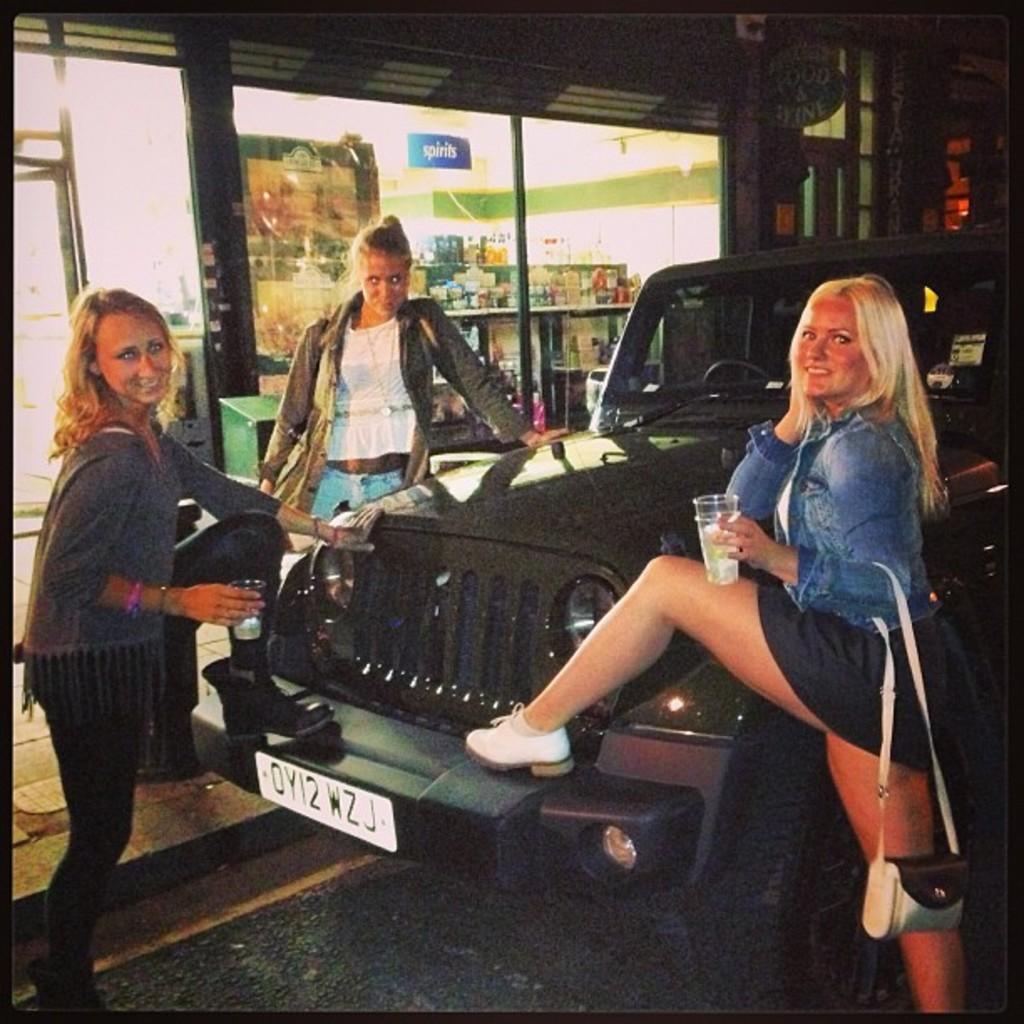Can you describe this image briefly? In the picture I can see 3 women among them two men are holding glasses in hands. In the background I can see a vehicle, framed glass wall, shelf which has objects and some other objects on the ground. 